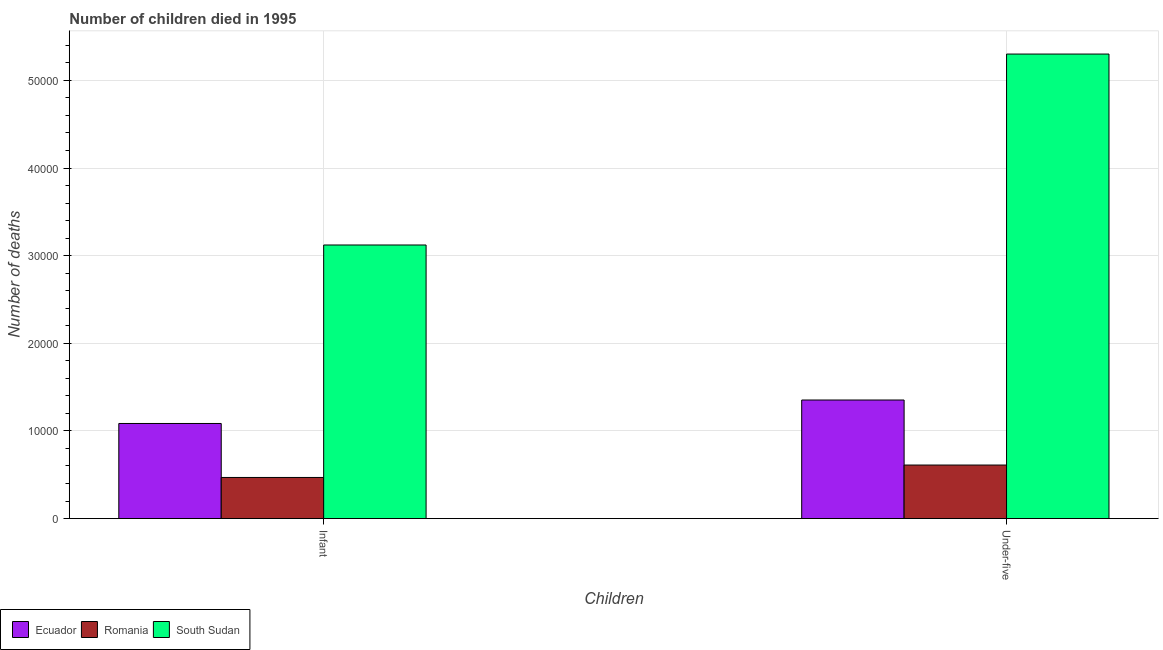How many different coloured bars are there?
Provide a short and direct response. 3. Are the number of bars per tick equal to the number of legend labels?
Offer a very short reply. Yes. Are the number of bars on each tick of the X-axis equal?
Keep it short and to the point. Yes. What is the label of the 1st group of bars from the left?
Your answer should be compact. Infant. What is the number of infant deaths in Romania?
Offer a very short reply. 4691. Across all countries, what is the maximum number of under-five deaths?
Provide a succinct answer. 5.30e+04. Across all countries, what is the minimum number of under-five deaths?
Your answer should be compact. 6108. In which country was the number of infant deaths maximum?
Make the answer very short. South Sudan. In which country was the number of infant deaths minimum?
Ensure brevity in your answer.  Romania. What is the total number of infant deaths in the graph?
Provide a succinct answer. 4.68e+04. What is the difference between the number of under-five deaths in South Sudan and that in Romania?
Your response must be concise. 4.69e+04. What is the difference between the number of infant deaths in South Sudan and the number of under-five deaths in Ecuador?
Make the answer very short. 1.77e+04. What is the average number of under-five deaths per country?
Keep it short and to the point. 2.42e+04. What is the difference between the number of infant deaths and number of under-five deaths in South Sudan?
Give a very brief answer. -2.18e+04. What is the ratio of the number of infant deaths in Romania to that in South Sudan?
Ensure brevity in your answer.  0.15. What does the 3rd bar from the left in Under-five represents?
Give a very brief answer. South Sudan. What does the 3rd bar from the right in Under-five represents?
Ensure brevity in your answer.  Ecuador. How many bars are there?
Your answer should be compact. 6. What is the difference between two consecutive major ticks on the Y-axis?
Give a very brief answer. 10000. Are the values on the major ticks of Y-axis written in scientific E-notation?
Provide a succinct answer. No. Does the graph contain any zero values?
Your response must be concise. No. Does the graph contain grids?
Offer a very short reply. Yes. What is the title of the graph?
Make the answer very short. Number of children died in 1995. Does "Cabo Verde" appear as one of the legend labels in the graph?
Make the answer very short. No. What is the label or title of the X-axis?
Offer a terse response. Children. What is the label or title of the Y-axis?
Provide a succinct answer. Number of deaths. What is the Number of deaths of Ecuador in Infant?
Your answer should be compact. 1.09e+04. What is the Number of deaths in Romania in Infant?
Offer a terse response. 4691. What is the Number of deaths of South Sudan in Infant?
Provide a succinct answer. 3.12e+04. What is the Number of deaths of Ecuador in Under-five?
Your response must be concise. 1.35e+04. What is the Number of deaths of Romania in Under-five?
Your answer should be compact. 6108. What is the Number of deaths in South Sudan in Under-five?
Your answer should be compact. 5.30e+04. Across all Children, what is the maximum Number of deaths in Ecuador?
Keep it short and to the point. 1.35e+04. Across all Children, what is the maximum Number of deaths of Romania?
Keep it short and to the point. 6108. Across all Children, what is the maximum Number of deaths in South Sudan?
Your response must be concise. 5.30e+04. Across all Children, what is the minimum Number of deaths in Ecuador?
Give a very brief answer. 1.09e+04. Across all Children, what is the minimum Number of deaths in Romania?
Offer a very short reply. 4691. Across all Children, what is the minimum Number of deaths in South Sudan?
Your response must be concise. 3.12e+04. What is the total Number of deaths in Ecuador in the graph?
Offer a terse response. 2.44e+04. What is the total Number of deaths of Romania in the graph?
Make the answer very short. 1.08e+04. What is the total Number of deaths in South Sudan in the graph?
Provide a succinct answer. 8.42e+04. What is the difference between the Number of deaths in Ecuador in Infant and that in Under-five?
Provide a succinct answer. -2678. What is the difference between the Number of deaths of Romania in Infant and that in Under-five?
Keep it short and to the point. -1417. What is the difference between the Number of deaths of South Sudan in Infant and that in Under-five?
Offer a very short reply. -2.18e+04. What is the difference between the Number of deaths of Ecuador in Infant and the Number of deaths of Romania in Under-five?
Make the answer very short. 4743. What is the difference between the Number of deaths of Ecuador in Infant and the Number of deaths of South Sudan in Under-five?
Give a very brief answer. -4.22e+04. What is the difference between the Number of deaths in Romania in Infant and the Number of deaths in South Sudan in Under-five?
Offer a very short reply. -4.83e+04. What is the average Number of deaths of Ecuador per Children?
Offer a very short reply. 1.22e+04. What is the average Number of deaths in Romania per Children?
Give a very brief answer. 5399.5. What is the average Number of deaths in South Sudan per Children?
Keep it short and to the point. 4.21e+04. What is the difference between the Number of deaths of Ecuador and Number of deaths of Romania in Infant?
Your answer should be very brief. 6160. What is the difference between the Number of deaths of Ecuador and Number of deaths of South Sudan in Infant?
Your answer should be very brief. -2.04e+04. What is the difference between the Number of deaths in Romania and Number of deaths in South Sudan in Infant?
Provide a succinct answer. -2.65e+04. What is the difference between the Number of deaths of Ecuador and Number of deaths of Romania in Under-five?
Provide a short and direct response. 7421. What is the difference between the Number of deaths of Ecuador and Number of deaths of South Sudan in Under-five?
Your answer should be very brief. -3.95e+04. What is the difference between the Number of deaths in Romania and Number of deaths in South Sudan in Under-five?
Provide a succinct answer. -4.69e+04. What is the ratio of the Number of deaths in Ecuador in Infant to that in Under-five?
Your response must be concise. 0.8. What is the ratio of the Number of deaths of Romania in Infant to that in Under-five?
Your answer should be compact. 0.77. What is the ratio of the Number of deaths in South Sudan in Infant to that in Under-five?
Provide a short and direct response. 0.59. What is the difference between the highest and the second highest Number of deaths of Ecuador?
Offer a very short reply. 2678. What is the difference between the highest and the second highest Number of deaths of Romania?
Your response must be concise. 1417. What is the difference between the highest and the second highest Number of deaths in South Sudan?
Give a very brief answer. 2.18e+04. What is the difference between the highest and the lowest Number of deaths in Ecuador?
Offer a terse response. 2678. What is the difference between the highest and the lowest Number of deaths in Romania?
Your response must be concise. 1417. What is the difference between the highest and the lowest Number of deaths in South Sudan?
Your response must be concise. 2.18e+04. 